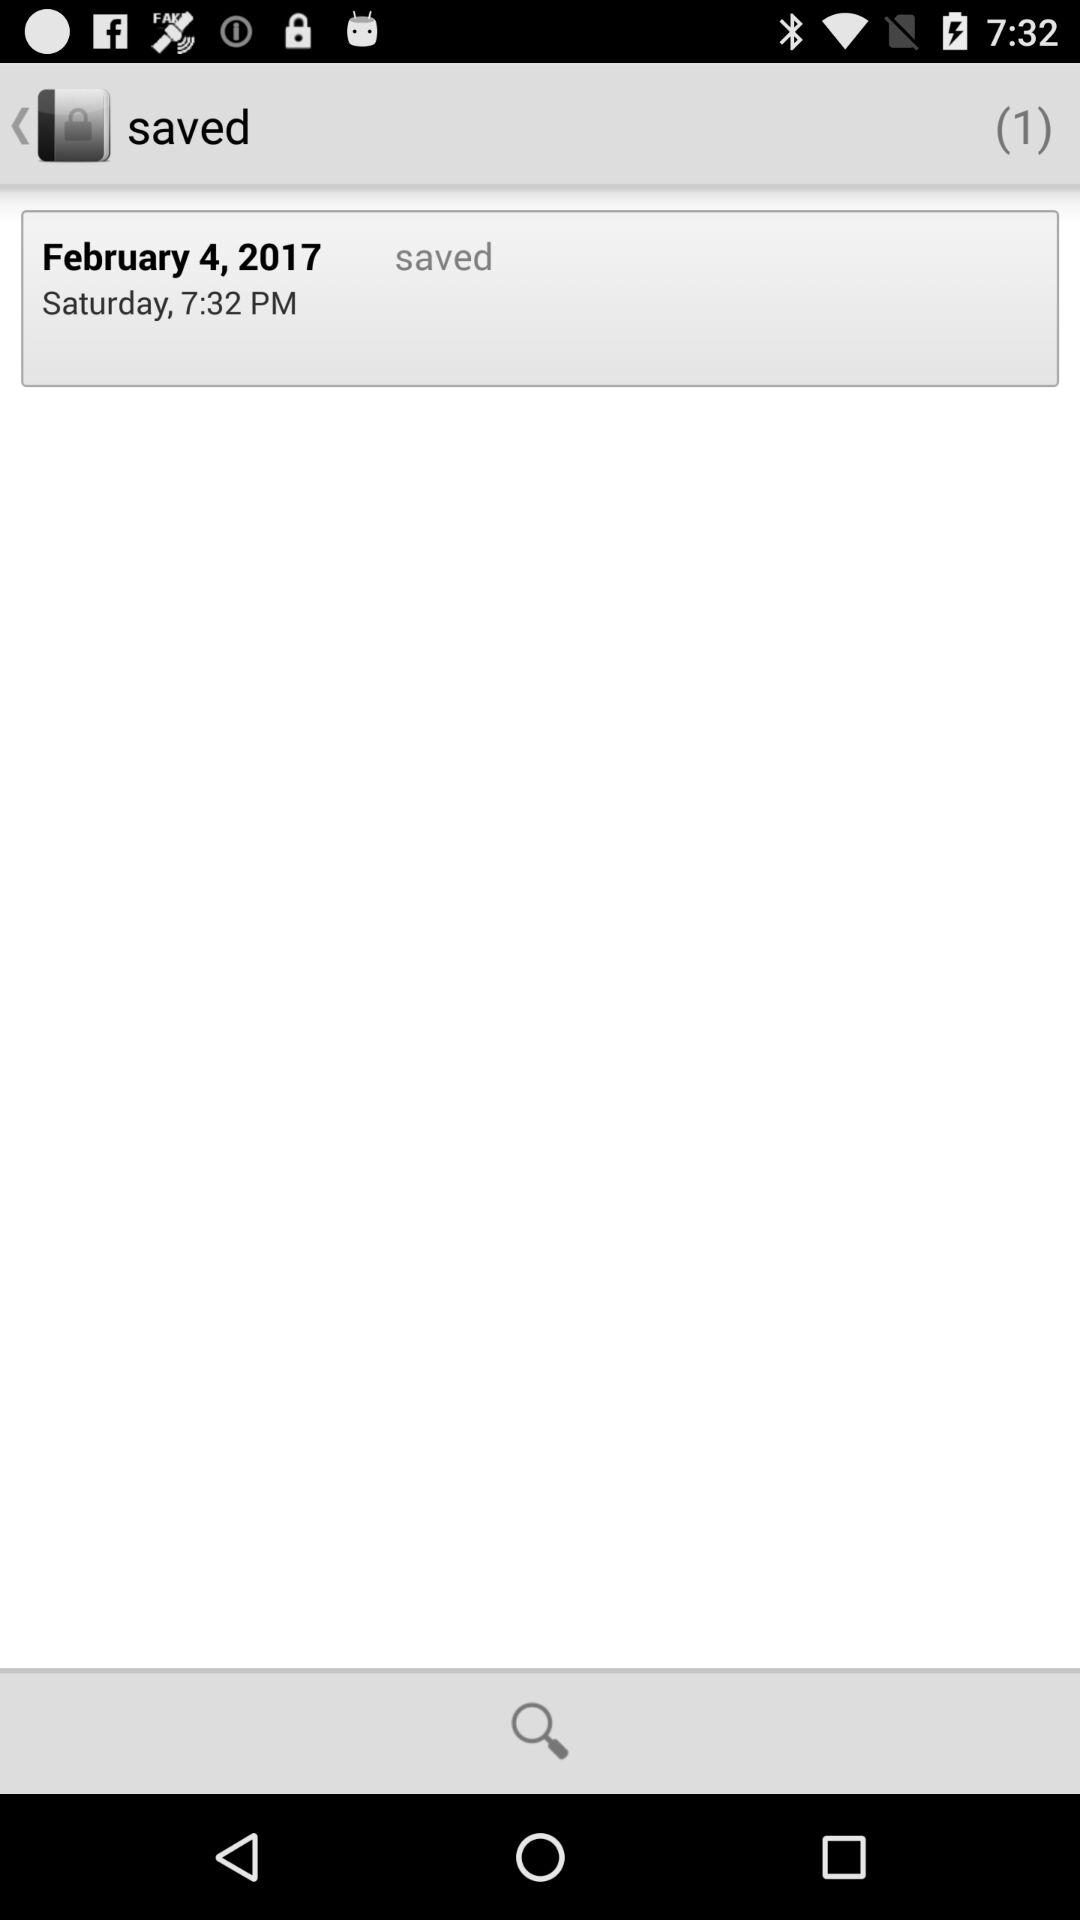On what day was the item saved? The item was saved on Saturday. 